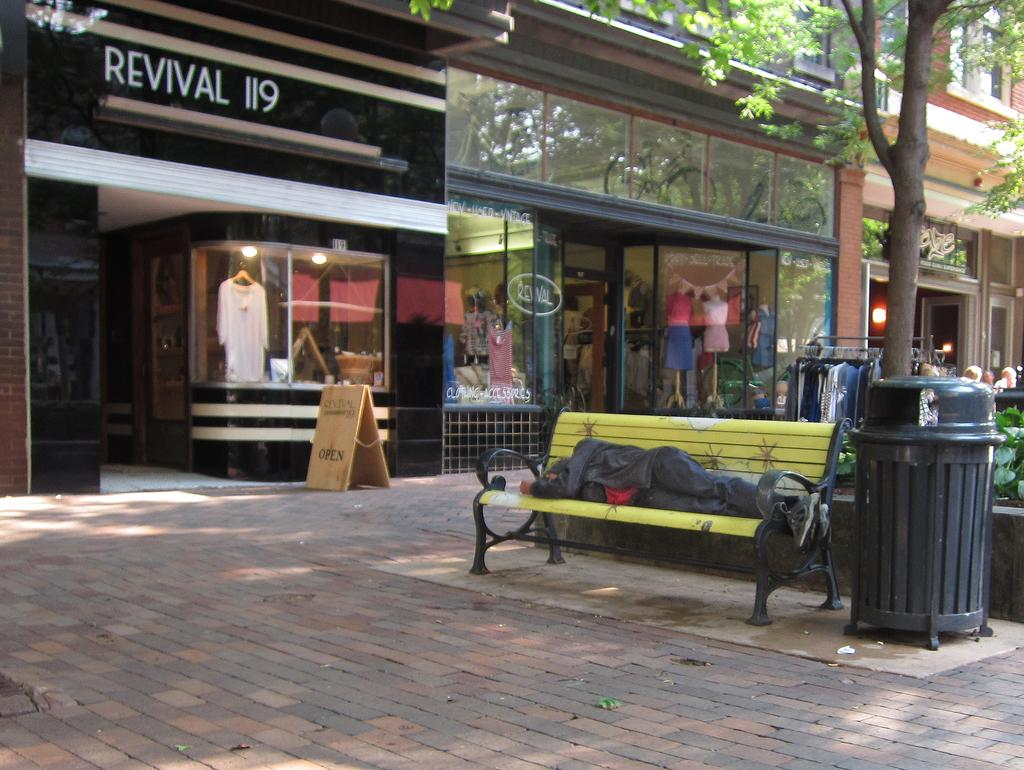What is the person in the image doing? There is a person sleeping on a bench in the image. What can be seen near the person? There is a trash bin in the image. What type of vegetation is present in the image? There is a tree in the image. What might be used for hanging clothes? Clothes are hanging on hangers in the image. Where are the people located in the image? People are present on the right side of the image. What can be seen in the distance in the image? There are buildings in the background of the image. What type of flesh can be seen on the edge of the bench in the image? There is no flesh visible on the edge of the bench in the image. 